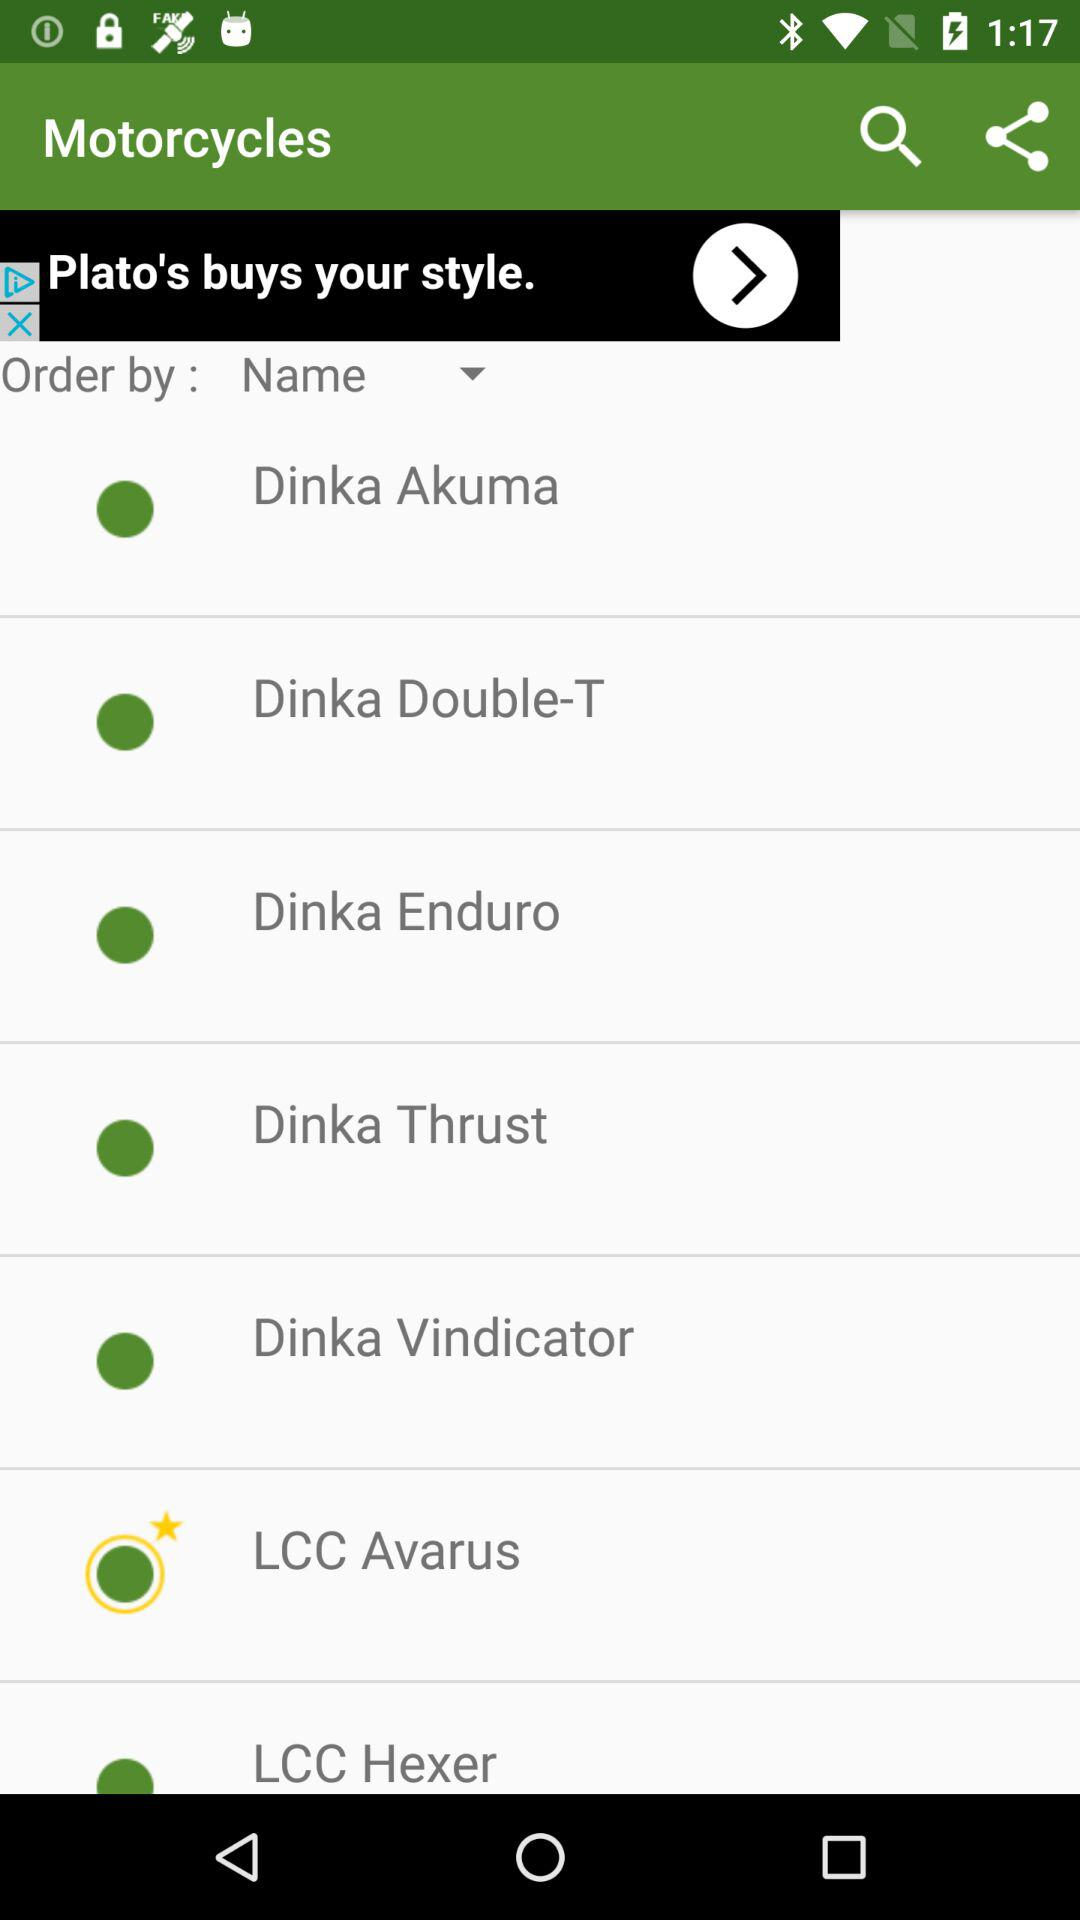Which option is selected as favorites? The option is "LCC Avarus". 